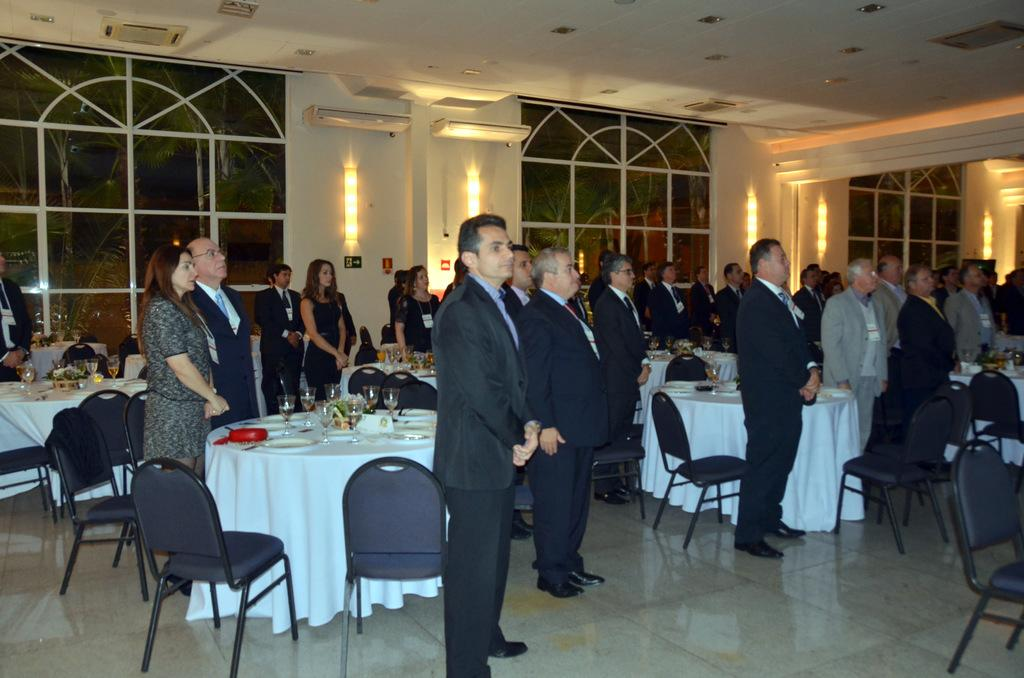What type of structure can be seen in the image? There is a wall in the image. What can be seen on the wall? There are windows in the image. Who or what is present in the image? There are people standing in the image. What type of furniture is visible in the image? There are chairs and tables in the image. What items can be seen on the tables? There are plates, bowls, and glasses on the tables. What type of club does the owner use to change the plates on the tables? There is no club or owner mentioned in the image, and no information about changing plates is provided. 